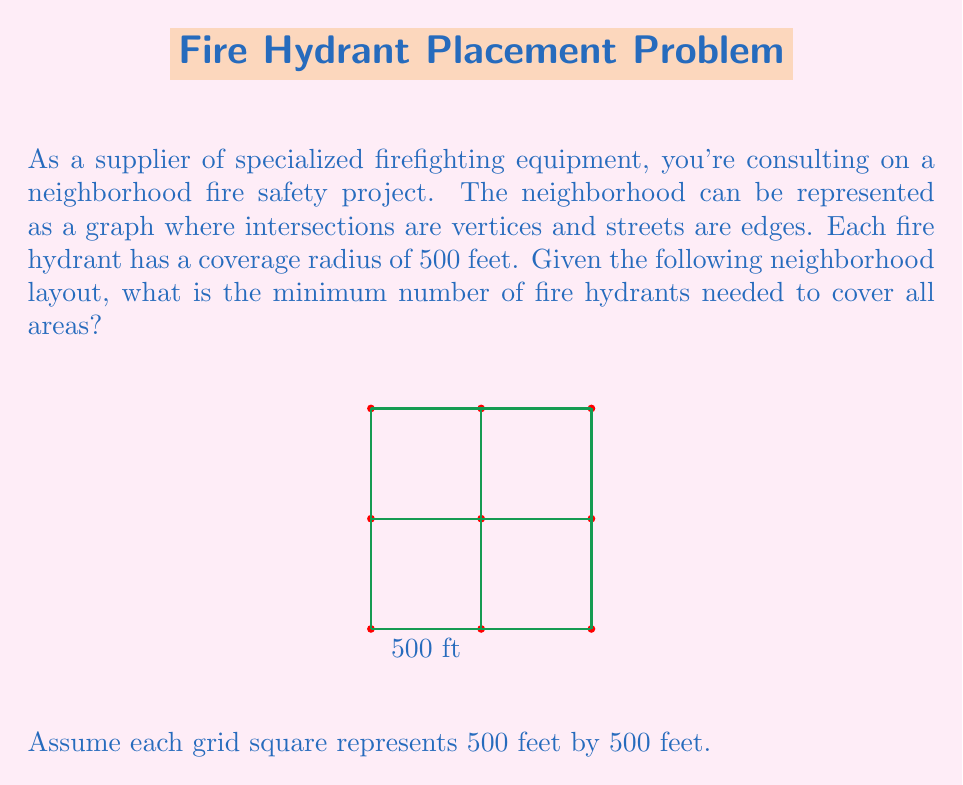Could you help me with this problem? To solve this problem, we need to use the concept of dominating sets in graph theory. A dominating set is a subset of vertices in a graph such that every vertex not in the subset is adjacent to at least one vertex in the subset.

Step 1: Analyze the graph structure
The given neighborhood layout is a 3x3 grid graph with 9 vertices (intersections) and 12 edges (streets).

Step 2: Determine the coverage of each hydrant
Each hydrant covers its location and all adjacent intersections. In a grid graph, this means each hydrant covers itself and up to 4 neighboring intersections.

Step 3: Find the minimum dominating set
For a 3x3 grid graph, the minimum dominating set consists of the four corner vertices. This can be verified as follows:

- Placing hydrants at (0,0) and (10,10) covers 6 out of 9 intersections
- The remaining uncovered intersections are (5,5), (10,0), and (0,10)
- Placing hydrants at (10,0) and (0,10) covers these remaining intersections

Step 4: Verify coverage
With hydrants at (0,0), (10,0), (0,10), and (10,10):
- (0,0) covers (0,0), (5,0), and (0,5)
- (10,0) covers (10,0), (5,0), and (10,5)
- (0,10) covers (0,10), (0,5), and (5,10)
- (10,10) covers (10,10), (10,5), and (5,10)
- (5,5) is covered by all four hydrants

Therefore, all intersections are covered with 4 hydrants, which is the minimum number possible for this layout.
Answer: 4 fire hydrants 